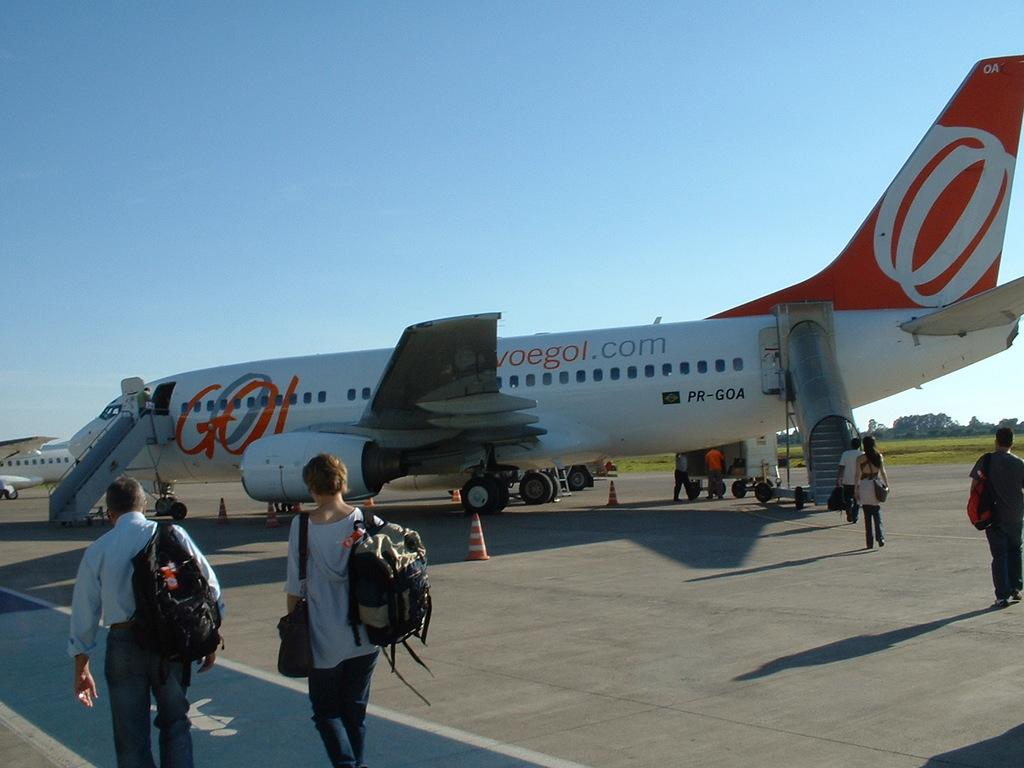Provide a one-sentence caption for the provided image. An orange and white passenger airplane sports a colorful "GO" between its wing and its door. 